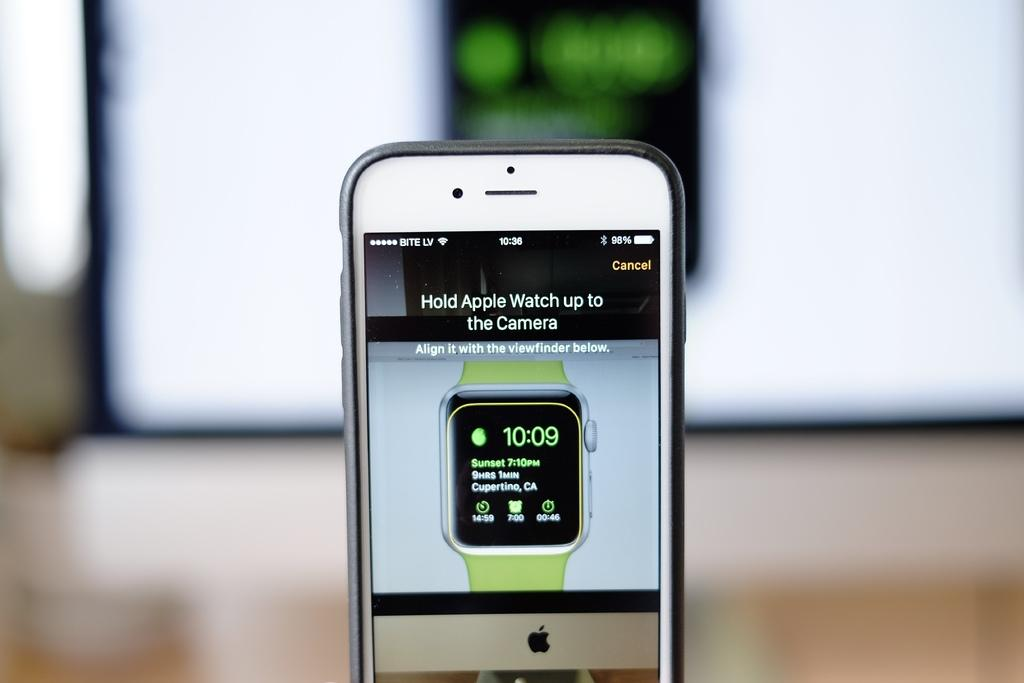<image>
Summarize the visual content of the image. an Iphone display shows the time as 10:09 